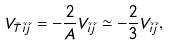Convert formula to latex. <formula><loc_0><loc_0><loc_500><loc_500>V _ { \tilde { T } \tilde { i } \tilde { j } } = - \frac { 2 } { A } V _ { \tilde { i } \tilde { j } } \simeq - \frac { 2 } { 3 } V _ { \tilde { i } \tilde { j } } ,</formula> 